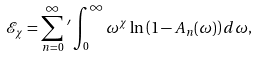Convert formula to latex. <formula><loc_0><loc_0><loc_500><loc_500>\mathcal { E } _ { \chi } = \sum _ { n = 0 } ^ { \infty } \, ^ { \prime } \int _ { 0 } ^ { \infty } \omega ^ { \chi } \ln \left ( 1 - A _ { n } ( \omega ) \right ) d \omega ,</formula> 